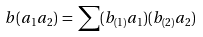<formula> <loc_0><loc_0><loc_500><loc_500>b ( a _ { 1 } a _ { 2 } ) \, = \, \sum ( b _ { ( 1 ) } a _ { 1 } ) ( b _ { ( 2 ) } a _ { 2 } )</formula> 